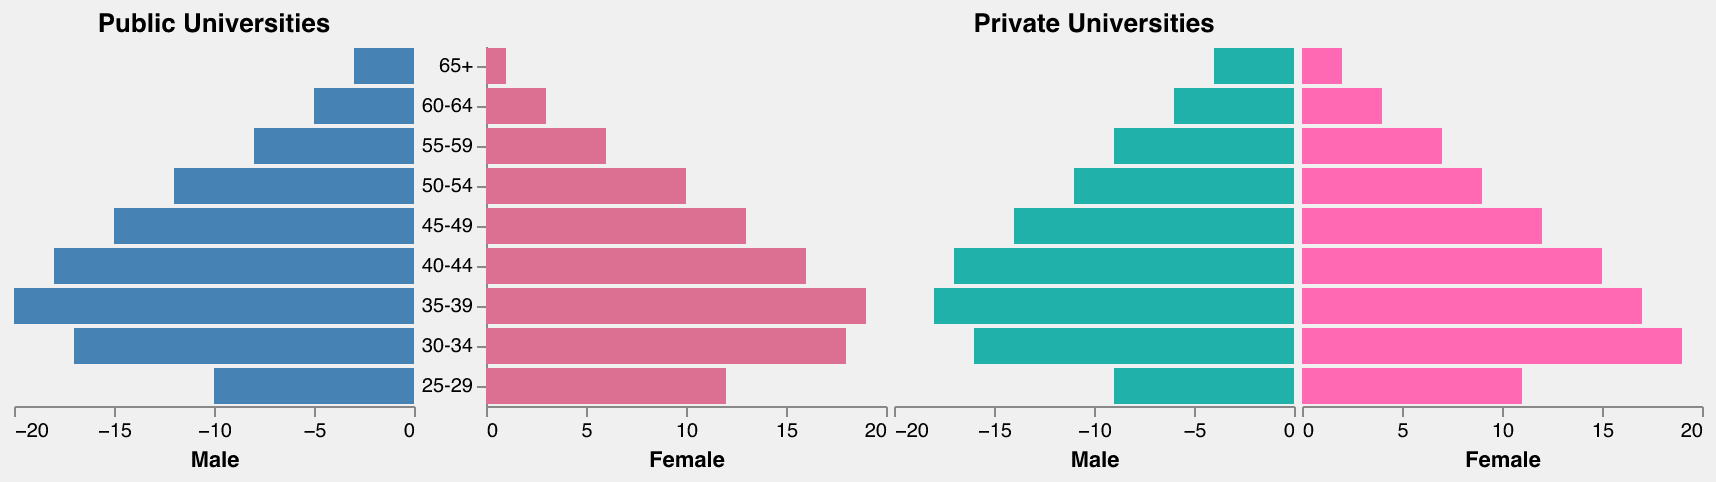How are the faculty members distributed by age in public universities? By looking at the population pyramid, we can see the age distribution from the 25-29 age group to the 65+ age group. The number of male and female faculty members are distinctly marked on the respective sides of the pyramid for each age group.
Answer: Distributed from 25-29 to 65+ Which age group has the highest number of male faculty members in public universities? By examining the left side of the population pyramid for public universities, we observe the bars corresponding to the highest value. The 35-39 age group has the longest bar for male faculty members.
Answer: 35-39 What is the total number of female faculty members aged 30-34 across both public and private universities? Look at the bars representing female faculty members in the 30-34 age group in both public and private universities, then add these values together (18 from public and 19 from private).
Answer: 37 Which university type has more female faculty members in the 60-64 age group? Compare the bars representing female faculty members in the 60-64 age group on the public side and the private side.
Answer: Private universities Is there a significant difference in the number of male faculty members aged 55-59 between public and private universities? Compare the bars representing male faculty members aged 55-59 in both public and private universities. Both groups have similar values (public: 8, private: 9).
Answer: No significant difference Which age group has the most balanced gender distribution in public universities? Compare the length of bars for male and female faculty members across each age group in public universities. The 30-34 age group has the most balanced distribution (17 males and 18 females).
Answer: 30-34 How does the number of faculty members aged 25-29 in private universities compare to those aged 40-44? Compare the values for the 25-29 age group (9 males and 11 females) and the 40-44 age group (17 males and 15 females) in private universities. The 40-44 age group has more faculty members.
Answer: More in 40-44 Are there more senior faculty members (60+) in public or private universities? Add the faculty members aged 65+ and 60-64 in public and private universities. For public, 65+ (3 males + 1 female) + 60-64 (5 males + 3 females) = 12. For private, 65+ (4 males + 2 females) + 60-64 (6 males + 4 females) = 16.
Answer: Private universities Which age group in public universities has the largest gender disparity? Look for the age group with the most significant difference between male and female faculty members in public universities. This is 35-39 (20 males, 19 females).
Answer: 35-39 